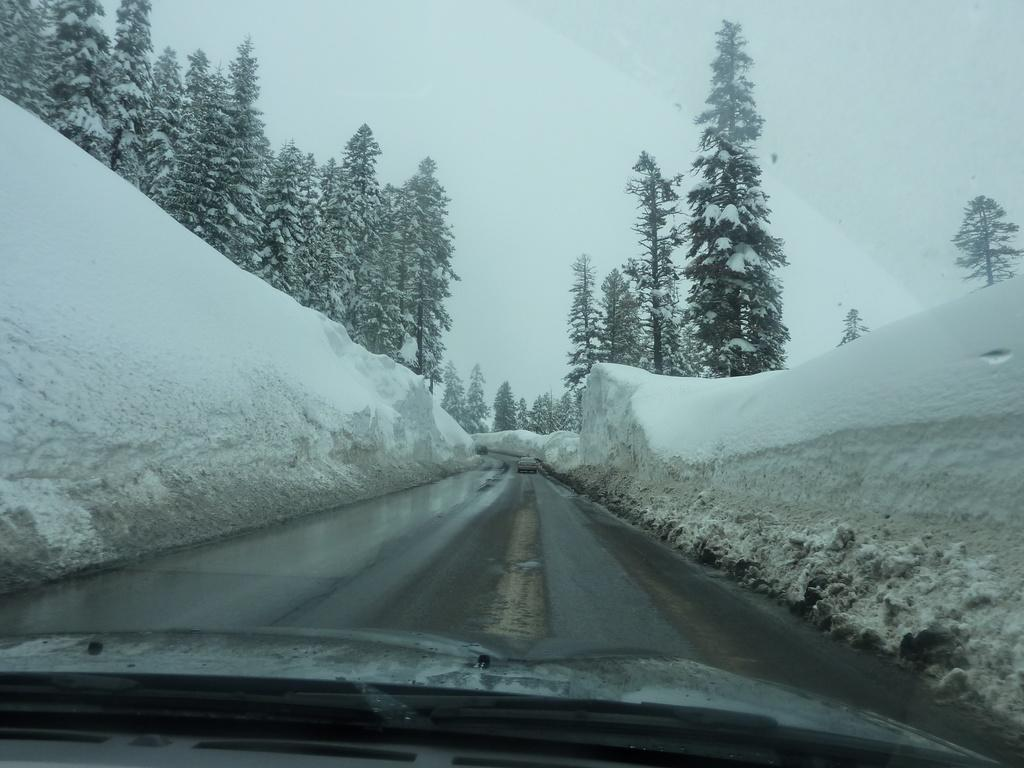What is the main feature of the image? There is a road in the image. What surrounds the road on both sides? There are snow walls on both sides of the road. What type of vegetation can be seen in the image? There are trees in the image. What is the weather condition in the image? There is snow visible in the image, indicating a snowy environment. What can be seen in the background of the image? There are mountains in the background of the image. What type of wood is used to build the country in the image? There is no country present in the image, and therefore no wood or building materials can be identified. 